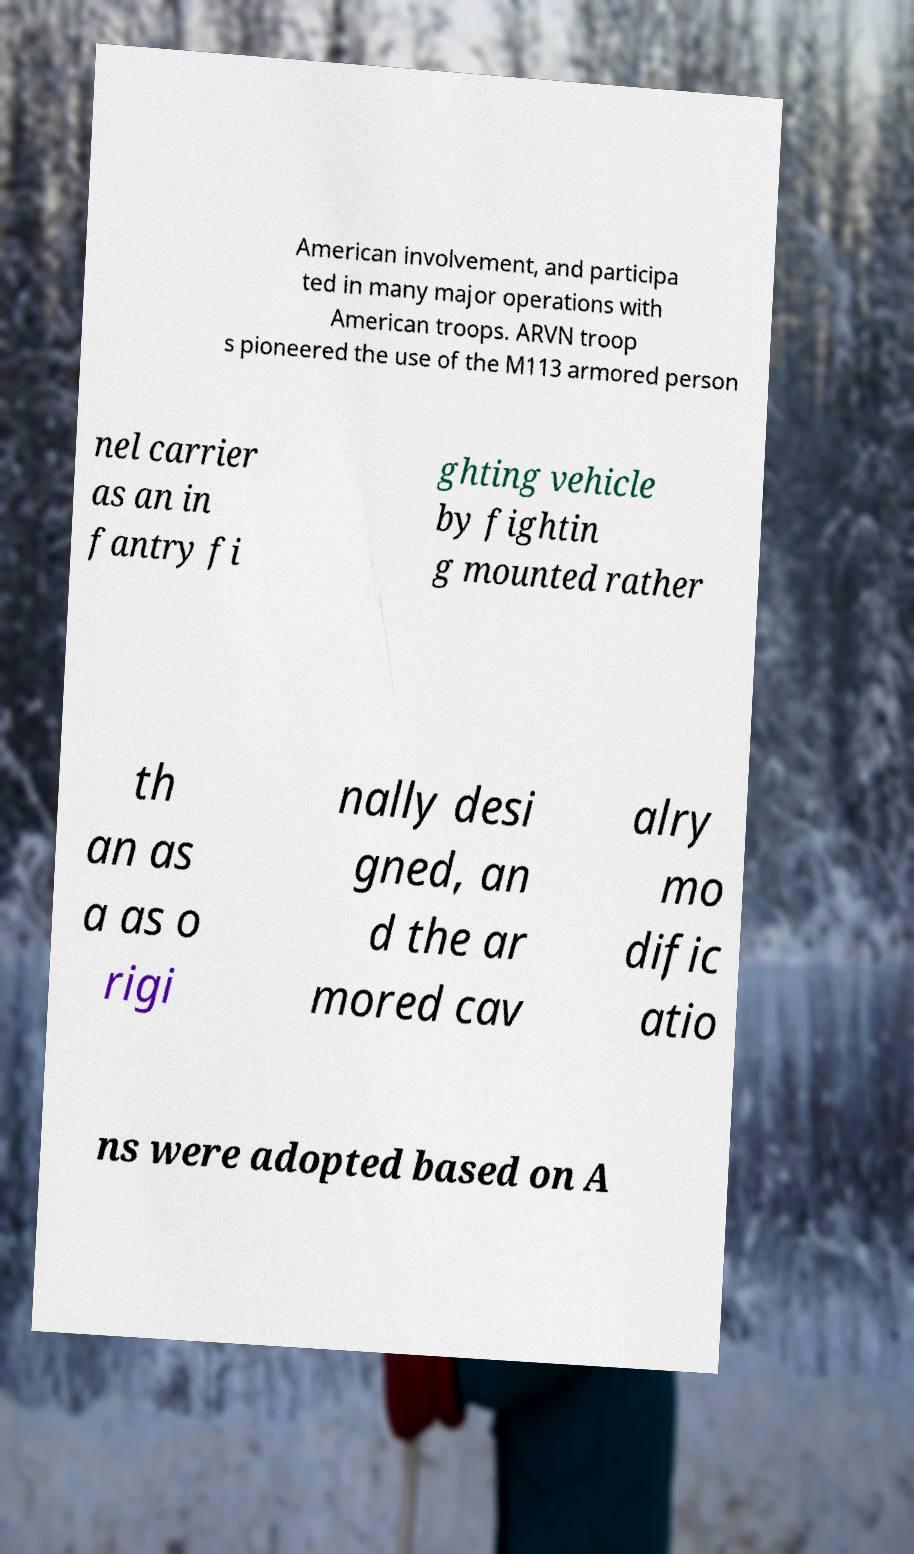Could you assist in decoding the text presented in this image and type it out clearly? American involvement, and participa ted in many major operations with American troops. ARVN troop s pioneered the use of the M113 armored person nel carrier as an in fantry fi ghting vehicle by fightin g mounted rather th an as a as o rigi nally desi gned, an d the ar mored cav alry mo dific atio ns were adopted based on A 